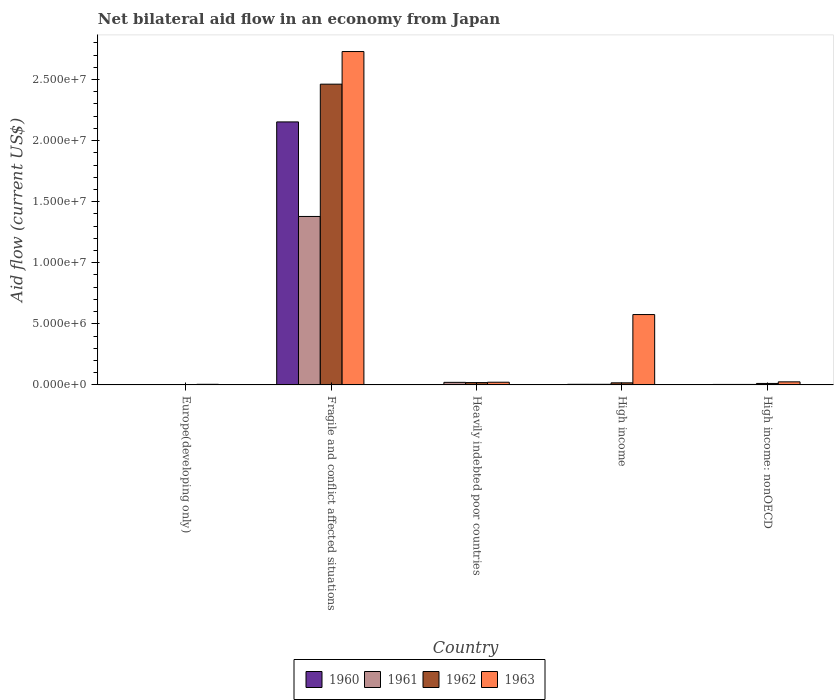How many groups of bars are there?
Your answer should be very brief. 5. Are the number of bars per tick equal to the number of legend labels?
Your answer should be compact. Yes. How many bars are there on the 1st tick from the left?
Ensure brevity in your answer.  4. What is the label of the 3rd group of bars from the left?
Ensure brevity in your answer.  Heavily indebted poor countries. In how many cases, is the number of bars for a given country not equal to the number of legend labels?
Offer a very short reply. 0. Across all countries, what is the maximum net bilateral aid flow in 1963?
Provide a short and direct response. 2.73e+07. Across all countries, what is the minimum net bilateral aid flow in 1960?
Provide a short and direct response. 10000. In which country was the net bilateral aid flow in 1960 maximum?
Offer a terse response. Fragile and conflict affected situations. In which country was the net bilateral aid flow in 1961 minimum?
Offer a very short reply. Europe(developing only). What is the total net bilateral aid flow in 1961 in the graph?
Make the answer very short. 1.41e+07. What is the difference between the net bilateral aid flow in 1962 in Fragile and conflict affected situations and the net bilateral aid flow in 1963 in High income?
Your answer should be compact. 1.89e+07. What is the average net bilateral aid flow in 1962 per country?
Make the answer very short. 5.03e+06. What is the difference between the net bilateral aid flow of/in 1961 and net bilateral aid flow of/in 1960 in Heavily indebted poor countries?
Your answer should be compact. 1.90e+05. In how many countries, is the net bilateral aid flow in 1963 greater than 19000000 US$?
Keep it short and to the point. 1. What is the ratio of the net bilateral aid flow in 1961 in Europe(developing only) to that in High income: nonOECD?
Offer a terse response. 0.75. Is the net bilateral aid flow in 1962 in Europe(developing only) less than that in High income: nonOECD?
Ensure brevity in your answer.  Yes. What is the difference between the highest and the second highest net bilateral aid flow in 1960?
Ensure brevity in your answer.  2.15e+07. What is the difference between the highest and the lowest net bilateral aid flow in 1962?
Provide a short and direct response. 2.46e+07. Is the sum of the net bilateral aid flow in 1961 in Europe(developing only) and High income: nonOECD greater than the maximum net bilateral aid flow in 1963 across all countries?
Provide a succinct answer. No. Is it the case that in every country, the sum of the net bilateral aid flow in 1961 and net bilateral aid flow in 1963 is greater than the sum of net bilateral aid flow in 1960 and net bilateral aid flow in 1962?
Make the answer very short. No. What does the 2nd bar from the left in High income: nonOECD represents?
Ensure brevity in your answer.  1961. What does the 2nd bar from the right in Heavily indebted poor countries represents?
Make the answer very short. 1962. What is the difference between two consecutive major ticks on the Y-axis?
Provide a succinct answer. 5.00e+06. How are the legend labels stacked?
Your answer should be very brief. Horizontal. What is the title of the graph?
Offer a very short reply. Net bilateral aid flow in an economy from Japan. Does "1968" appear as one of the legend labels in the graph?
Your answer should be very brief. No. What is the label or title of the Y-axis?
Give a very brief answer. Aid flow (current US$). What is the Aid flow (current US$) of 1961 in Europe(developing only)?
Offer a very short reply. 3.00e+04. What is the Aid flow (current US$) in 1963 in Europe(developing only)?
Give a very brief answer. 5.00e+04. What is the Aid flow (current US$) in 1960 in Fragile and conflict affected situations?
Provide a succinct answer. 2.15e+07. What is the Aid flow (current US$) of 1961 in Fragile and conflict affected situations?
Provide a succinct answer. 1.38e+07. What is the Aid flow (current US$) of 1962 in Fragile and conflict affected situations?
Offer a very short reply. 2.46e+07. What is the Aid flow (current US$) of 1963 in Fragile and conflict affected situations?
Ensure brevity in your answer.  2.73e+07. What is the Aid flow (current US$) of 1960 in Heavily indebted poor countries?
Your response must be concise. 2.00e+04. What is the Aid flow (current US$) of 1962 in Heavily indebted poor countries?
Your response must be concise. 1.90e+05. What is the Aid flow (current US$) of 1960 in High income?
Provide a succinct answer. 5.00e+04. What is the Aid flow (current US$) in 1961 in High income?
Provide a short and direct response. 5.00e+04. What is the Aid flow (current US$) of 1963 in High income?
Offer a very short reply. 5.76e+06. What is the Aid flow (current US$) in 1961 in High income: nonOECD?
Make the answer very short. 4.00e+04. What is the Aid flow (current US$) of 1962 in High income: nonOECD?
Give a very brief answer. 1.20e+05. What is the Aid flow (current US$) in 1963 in High income: nonOECD?
Your answer should be very brief. 2.50e+05. Across all countries, what is the maximum Aid flow (current US$) of 1960?
Provide a short and direct response. 2.15e+07. Across all countries, what is the maximum Aid flow (current US$) of 1961?
Your response must be concise. 1.38e+07. Across all countries, what is the maximum Aid flow (current US$) of 1962?
Your answer should be compact. 2.46e+07. Across all countries, what is the maximum Aid flow (current US$) in 1963?
Your response must be concise. 2.73e+07. Across all countries, what is the minimum Aid flow (current US$) of 1960?
Your answer should be compact. 10000. Across all countries, what is the minimum Aid flow (current US$) in 1961?
Ensure brevity in your answer.  3.00e+04. Across all countries, what is the minimum Aid flow (current US$) of 1962?
Offer a terse response. 3.00e+04. Across all countries, what is the minimum Aid flow (current US$) in 1963?
Keep it short and to the point. 5.00e+04. What is the total Aid flow (current US$) of 1960 in the graph?
Your answer should be compact. 2.16e+07. What is the total Aid flow (current US$) in 1961 in the graph?
Offer a terse response. 1.41e+07. What is the total Aid flow (current US$) of 1962 in the graph?
Keep it short and to the point. 2.51e+07. What is the total Aid flow (current US$) of 1963 in the graph?
Your answer should be very brief. 3.36e+07. What is the difference between the Aid flow (current US$) of 1960 in Europe(developing only) and that in Fragile and conflict affected situations?
Your answer should be compact. -2.15e+07. What is the difference between the Aid flow (current US$) in 1961 in Europe(developing only) and that in Fragile and conflict affected situations?
Your answer should be compact. -1.38e+07. What is the difference between the Aid flow (current US$) of 1962 in Europe(developing only) and that in Fragile and conflict affected situations?
Make the answer very short. -2.46e+07. What is the difference between the Aid flow (current US$) in 1963 in Europe(developing only) and that in Fragile and conflict affected situations?
Give a very brief answer. -2.72e+07. What is the difference between the Aid flow (current US$) in 1960 in Europe(developing only) and that in Heavily indebted poor countries?
Offer a very short reply. -10000. What is the difference between the Aid flow (current US$) of 1961 in Europe(developing only) and that in Heavily indebted poor countries?
Provide a succinct answer. -1.80e+05. What is the difference between the Aid flow (current US$) in 1960 in Europe(developing only) and that in High income?
Your answer should be compact. -4.00e+04. What is the difference between the Aid flow (current US$) of 1962 in Europe(developing only) and that in High income?
Ensure brevity in your answer.  -1.40e+05. What is the difference between the Aid flow (current US$) of 1963 in Europe(developing only) and that in High income?
Ensure brevity in your answer.  -5.71e+06. What is the difference between the Aid flow (current US$) in 1960 in Europe(developing only) and that in High income: nonOECD?
Make the answer very short. -3.00e+04. What is the difference between the Aid flow (current US$) in 1962 in Europe(developing only) and that in High income: nonOECD?
Give a very brief answer. -9.00e+04. What is the difference between the Aid flow (current US$) of 1963 in Europe(developing only) and that in High income: nonOECD?
Your response must be concise. -2.00e+05. What is the difference between the Aid flow (current US$) in 1960 in Fragile and conflict affected situations and that in Heavily indebted poor countries?
Give a very brief answer. 2.15e+07. What is the difference between the Aid flow (current US$) in 1961 in Fragile and conflict affected situations and that in Heavily indebted poor countries?
Make the answer very short. 1.36e+07. What is the difference between the Aid flow (current US$) of 1962 in Fragile and conflict affected situations and that in Heavily indebted poor countries?
Your answer should be very brief. 2.44e+07. What is the difference between the Aid flow (current US$) of 1963 in Fragile and conflict affected situations and that in Heavily indebted poor countries?
Your answer should be compact. 2.71e+07. What is the difference between the Aid flow (current US$) in 1960 in Fragile and conflict affected situations and that in High income?
Ensure brevity in your answer.  2.15e+07. What is the difference between the Aid flow (current US$) of 1961 in Fragile and conflict affected situations and that in High income?
Provide a short and direct response. 1.37e+07. What is the difference between the Aid flow (current US$) in 1962 in Fragile and conflict affected situations and that in High income?
Offer a very short reply. 2.44e+07. What is the difference between the Aid flow (current US$) in 1963 in Fragile and conflict affected situations and that in High income?
Offer a very short reply. 2.15e+07. What is the difference between the Aid flow (current US$) in 1960 in Fragile and conflict affected situations and that in High income: nonOECD?
Give a very brief answer. 2.15e+07. What is the difference between the Aid flow (current US$) in 1961 in Fragile and conflict affected situations and that in High income: nonOECD?
Ensure brevity in your answer.  1.38e+07. What is the difference between the Aid flow (current US$) of 1962 in Fragile and conflict affected situations and that in High income: nonOECD?
Offer a very short reply. 2.45e+07. What is the difference between the Aid flow (current US$) of 1963 in Fragile and conflict affected situations and that in High income: nonOECD?
Your answer should be compact. 2.70e+07. What is the difference between the Aid flow (current US$) in 1961 in Heavily indebted poor countries and that in High income?
Offer a very short reply. 1.60e+05. What is the difference between the Aid flow (current US$) in 1963 in Heavily indebted poor countries and that in High income?
Offer a terse response. -5.54e+06. What is the difference between the Aid flow (current US$) of 1960 in Heavily indebted poor countries and that in High income: nonOECD?
Ensure brevity in your answer.  -2.00e+04. What is the difference between the Aid flow (current US$) in 1961 in Heavily indebted poor countries and that in High income: nonOECD?
Your answer should be very brief. 1.70e+05. What is the difference between the Aid flow (current US$) of 1963 in Heavily indebted poor countries and that in High income: nonOECD?
Make the answer very short. -3.00e+04. What is the difference between the Aid flow (current US$) in 1962 in High income and that in High income: nonOECD?
Give a very brief answer. 5.00e+04. What is the difference between the Aid flow (current US$) in 1963 in High income and that in High income: nonOECD?
Keep it short and to the point. 5.51e+06. What is the difference between the Aid flow (current US$) of 1960 in Europe(developing only) and the Aid flow (current US$) of 1961 in Fragile and conflict affected situations?
Offer a very short reply. -1.38e+07. What is the difference between the Aid flow (current US$) in 1960 in Europe(developing only) and the Aid flow (current US$) in 1962 in Fragile and conflict affected situations?
Offer a terse response. -2.46e+07. What is the difference between the Aid flow (current US$) in 1960 in Europe(developing only) and the Aid flow (current US$) in 1963 in Fragile and conflict affected situations?
Your answer should be very brief. -2.73e+07. What is the difference between the Aid flow (current US$) of 1961 in Europe(developing only) and the Aid flow (current US$) of 1962 in Fragile and conflict affected situations?
Keep it short and to the point. -2.46e+07. What is the difference between the Aid flow (current US$) in 1961 in Europe(developing only) and the Aid flow (current US$) in 1963 in Fragile and conflict affected situations?
Provide a succinct answer. -2.73e+07. What is the difference between the Aid flow (current US$) in 1962 in Europe(developing only) and the Aid flow (current US$) in 1963 in Fragile and conflict affected situations?
Provide a succinct answer. -2.73e+07. What is the difference between the Aid flow (current US$) in 1960 in Europe(developing only) and the Aid flow (current US$) in 1961 in Heavily indebted poor countries?
Make the answer very short. -2.00e+05. What is the difference between the Aid flow (current US$) of 1960 in Europe(developing only) and the Aid flow (current US$) of 1963 in Heavily indebted poor countries?
Provide a short and direct response. -2.10e+05. What is the difference between the Aid flow (current US$) of 1961 in Europe(developing only) and the Aid flow (current US$) of 1962 in Heavily indebted poor countries?
Provide a short and direct response. -1.60e+05. What is the difference between the Aid flow (current US$) of 1962 in Europe(developing only) and the Aid flow (current US$) of 1963 in Heavily indebted poor countries?
Make the answer very short. -1.90e+05. What is the difference between the Aid flow (current US$) in 1960 in Europe(developing only) and the Aid flow (current US$) in 1963 in High income?
Offer a terse response. -5.75e+06. What is the difference between the Aid flow (current US$) in 1961 in Europe(developing only) and the Aid flow (current US$) in 1963 in High income?
Give a very brief answer. -5.73e+06. What is the difference between the Aid flow (current US$) of 1962 in Europe(developing only) and the Aid flow (current US$) of 1963 in High income?
Make the answer very short. -5.73e+06. What is the difference between the Aid flow (current US$) of 1960 in Europe(developing only) and the Aid flow (current US$) of 1961 in High income: nonOECD?
Your response must be concise. -3.00e+04. What is the difference between the Aid flow (current US$) in 1960 in Europe(developing only) and the Aid flow (current US$) in 1963 in High income: nonOECD?
Your answer should be compact. -2.40e+05. What is the difference between the Aid flow (current US$) of 1961 in Europe(developing only) and the Aid flow (current US$) of 1962 in High income: nonOECD?
Ensure brevity in your answer.  -9.00e+04. What is the difference between the Aid flow (current US$) in 1960 in Fragile and conflict affected situations and the Aid flow (current US$) in 1961 in Heavily indebted poor countries?
Ensure brevity in your answer.  2.13e+07. What is the difference between the Aid flow (current US$) of 1960 in Fragile and conflict affected situations and the Aid flow (current US$) of 1962 in Heavily indebted poor countries?
Offer a terse response. 2.13e+07. What is the difference between the Aid flow (current US$) in 1960 in Fragile and conflict affected situations and the Aid flow (current US$) in 1963 in Heavily indebted poor countries?
Offer a terse response. 2.13e+07. What is the difference between the Aid flow (current US$) in 1961 in Fragile and conflict affected situations and the Aid flow (current US$) in 1962 in Heavily indebted poor countries?
Give a very brief answer. 1.36e+07. What is the difference between the Aid flow (current US$) in 1961 in Fragile and conflict affected situations and the Aid flow (current US$) in 1963 in Heavily indebted poor countries?
Ensure brevity in your answer.  1.36e+07. What is the difference between the Aid flow (current US$) of 1962 in Fragile and conflict affected situations and the Aid flow (current US$) of 1963 in Heavily indebted poor countries?
Ensure brevity in your answer.  2.44e+07. What is the difference between the Aid flow (current US$) of 1960 in Fragile and conflict affected situations and the Aid flow (current US$) of 1961 in High income?
Offer a terse response. 2.15e+07. What is the difference between the Aid flow (current US$) in 1960 in Fragile and conflict affected situations and the Aid flow (current US$) in 1962 in High income?
Provide a short and direct response. 2.14e+07. What is the difference between the Aid flow (current US$) of 1960 in Fragile and conflict affected situations and the Aid flow (current US$) of 1963 in High income?
Make the answer very short. 1.58e+07. What is the difference between the Aid flow (current US$) in 1961 in Fragile and conflict affected situations and the Aid flow (current US$) in 1962 in High income?
Provide a succinct answer. 1.36e+07. What is the difference between the Aid flow (current US$) in 1961 in Fragile and conflict affected situations and the Aid flow (current US$) in 1963 in High income?
Make the answer very short. 8.03e+06. What is the difference between the Aid flow (current US$) of 1962 in Fragile and conflict affected situations and the Aid flow (current US$) of 1963 in High income?
Make the answer very short. 1.89e+07. What is the difference between the Aid flow (current US$) of 1960 in Fragile and conflict affected situations and the Aid flow (current US$) of 1961 in High income: nonOECD?
Ensure brevity in your answer.  2.15e+07. What is the difference between the Aid flow (current US$) of 1960 in Fragile and conflict affected situations and the Aid flow (current US$) of 1962 in High income: nonOECD?
Offer a terse response. 2.14e+07. What is the difference between the Aid flow (current US$) in 1960 in Fragile and conflict affected situations and the Aid flow (current US$) in 1963 in High income: nonOECD?
Keep it short and to the point. 2.13e+07. What is the difference between the Aid flow (current US$) in 1961 in Fragile and conflict affected situations and the Aid flow (current US$) in 1962 in High income: nonOECD?
Keep it short and to the point. 1.37e+07. What is the difference between the Aid flow (current US$) of 1961 in Fragile and conflict affected situations and the Aid flow (current US$) of 1963 in High income: nonOECD?
Offer a terse response. 1.35e+07. What is the difference between the Aid flow (current US$) of 1962 in Fragile and conflict affected situations and the Aid flow (current US$) of 1963 in High income: nonOECD?
Give a very brief answer. 2.44e+07. What is the difference between the Aid flow (current US$) of 1960 in Heavily indebted poor countries and the Aid flow (current US$) of 1961 in High income?
Offer a very short reply. -3.00e+04. What is the difference between the Aid flow (current US$) of 1960 in Heavily indebted poor countries and the Aid flow (current US$) of 1963 in High income?
Give a very brief answer. -5.74e+06. What is the difference between the Aid flow (current US$) in 1961 in Heavily indebted poor countries and the Aid flow (current US$) in 1962 in High income?
Offer a very short reply. 4.00e+04. What is the difference between the Aid flow (current US$) of 1961 in Heavily indebted poor countries and the Aid flow (current US$) of 1963 in High income?
Offer a terse response. -5.55e+06. What is the difference between the Aid flow (current US$) in 1962 in Heavily indebted poor countries and the Aid flow (current US$) in 1963 in High income?
Your response must be concise. -5.57e+06. What is the difference between the Aid flow (current US$) in 1960 in Heavily indebted poor countries and the Aid flow (current US$) in 1961 in High income: nonOECD?
Provide a succinct answer. -2.00e+04. What is the difference between the Aid flow (current US$) in 1960 in Heavily indebted poor countries and the Aid flow (current US$) in 1963 in High income: nonOECD?
Your answer should be very brief. -2.30e+05. What is the difference between the Aid flow (current US$) in 1961 in Heavily indebted poor countries and the Aid flow (current US$) in 1963 in High income: nonOECD?
Make the answer very short. -4.00e+04. What is the difference between the Aid flow (current US$) in 1962 in Heavily indebted poor countries and the Aid flow (current US$) in 1963 in High income: nonOECD?
Give a very brief answer. -6.00e+04. What is the difference between the Aid flow (current US$) in 1960 in High income and the Aid flow (current US$) in 1961 in High income: nonOECD?
Your response must be concise. 10000. What is the difference between the Aid flow (current US$) in 1961 in High income and the Aid flow (current US$) in 1962 in High income: nonOECD?
Provide a succinct answer. -7.00e+04. What is the difference between the Aid flow (current US$) of 1961 in High income and the Aid flow (current US$) of 1963 in High income: nonOECD?
Keep it short and to the point. -2.00e+05. What is the difference between the Aid flow (current US$) of 1962 in High income and the Aid flow (current US$) of 1963 in High income: nonOECD?
Ensure brevity in your answer.  -8.00e+04. What is the average Aid flow (current US$) of 1960 per country?
Your response must be concise. 4.33e+06. What is the average Aid flow (current US$) in 1961 per country?
Make the answer very short. 2.82e+06. What is the average Aid flow (current US$) in 1962 per country?
Keep it short and to the point. 5.03e+06. What is the average Aid flow (current US$) in 1963 per country?
Your answer should be very brief. 6.71e+06. What is the difference between the Aid flow (current US$) of 1960 and Aid flow (current US$) of 1962 in Europe(developing only)?
Make the answer very short. -2.00e+04. What is the difference between the Aid flow (current US$) of 1961 and Aid flow (current US$) of 1962 in Europe(developing only)?
Your response must be concise. 0. What is the difference between the Aid flow (current US$) in 1961 and Aid flow (current US$) in 1963 in Europe(developing only)?
Give a very brief answer. -2.00e+04. What is the difference between the Aid flow (current US$) in 1962 and Aid flow (current US$) in 1963 in Europe(developing only)?
Your answer should be very brief. -2.00e+04. What is the difference between the Aid flow (current US$) of 1960 and Aid flow (current US$) of 1961 in Fragile and conflict affected situations?
Ensure brevity in your answer.  7.74e+06. What is the difference between the Aid flow (current US$) of 1960 and Aid flow (current US$) of 1962 in Fragile and conflict affected situations?
Provide a succinct answer. -3.09e+06. What is the difference between the Aid flow (current US$) in 1960 and Aid flow (current US$) in 1963 in Fragile and conflict affected situations?
Your response must be concise. -5.76e+06. What is the difference between the Aid flow (current US$) of 1961 and Aid flow (current US$) of 1962 in Fragile and conflict affected situations?
Provide a short and direct response. -1.08e+07. What is the difference between the Aid flow (current US$) in 1961 and Aid flow (current US$) in 1963 in Fragile and conflict affected situations?
Provide a short and direct response. -1.35e+07. What is the difference between the Aid flow (current US$) in 1962 and Aid flow (current US$) in 1963 in Fragile and conflict affected situations?
Ensure brevity in your answer.  -2.67e+06. What is the difference between the Aid flow (current US$) in 1960 and Aid flow (current US$) in 1961 in Heavily indebted poor countries?
Offer a very short reply. -1.90e+05. What is the difference between the Aid flow (current US$) of 1960 and Aid flow (current US$) of 1962 in Heavily indebted poor countries?
Provide a short and direct response. -1.70e+05. What is the difference between the Aid flow (current US$) of 1960 and Aid flow (current US$) of 1963 in Heavily indebted poor countries?
Keep it short and to the point. -2.00e+05. What is the difference between the Aid flow (current US$) in 1961 and Aid flow (current US$) in 1962 in Heavily indebted poor countries?
Offer a terse response. 2.00e+04. What is the difference between the Aid flow (current US$) of 1962 and Aid flow (current US$) of 1963 in Heavily indebted poor countries?
Your response must be concise. -3.00e+04. What is the difference between the Aid flow (current US$) in 1960 and Aid flow (current US$) in 1961 in High income?
Provide a succinct answer. 0. What is the difference between the Aid flow (current US$) in 1960 and Aid flow (current US$) in 1962 in High income?
Keep it short and to the point. -1.20e+05. What is the difference between the Aid flow (current US$) of 1960 and Aid flow (current US$) of 1963 in High income?
Provide a succinct answer. -5.71e+06. What is the difference between the Aid flow (current US$) of 1961 and Aid flow (current US$) of 1962 in High income?
Your answer should be very brief. -1.20e+05. What is the difference between the Aid flow (current US$) in 1961 and Aid flow (current US$) in 1963 in High income?
Offer a terse response. -5.71e+06. What is the difference between the Aid flow (current US$) of 1962 and Aid flow (current US$) of 1963 in High income?
Keep it short and to the point. -5.59e+06. What is the difference between the Aid flow (current US$) in 1960 and Aid flow (current US$) in 1961 in High income: nonOECD?
Give a very brief answer. 0. What is the difference between the Aid flow (current US$) in 1960 and Aid flow (current US$) in 1962 in High income: nonOECD?
Offer a very short reply. -8.00e+04. What is the difference between the Aid flow (current US$) of 1960 and Aid flow (current US$) of 1963 in High income: nonOECD?
Your response must be concise. -2.10e+05. What is the difference between the Aid flow (current US$) of 1961 and Aid flow (current US$) of 1963 in High income: nonOECD?
Your response must be concise. -2.10e+05. What is the ratio of the Aid flow (current US$) of 1960 in Europe(developing only) to that in Fragile and conflict affected situations?
Offer a terse response. 0. What is the ratio of the Aid flow (current US$) in 1961 in Europe(developing only) to that in Fragile and conflict affected situations?
Give a very brief answer. 0. What is the ratio of the Aid flow (current US$) of 1962 in Europe(developing only) to that in Fragile and conflict affected situations?
Offer a terse response. 0. What is the ratio of the Aid flow (current US$) in 1963 in Europe(developing only) to that in Fragile and conflict affected situations?
Offer a terse response. 0. What is the ratio of the Aid flow (current US$) in 1960 in Europe(developing only) to that in Heavily indebted poor countries?
Offer a very short reply. 0.5. What is the ratio of the Aid flow (current US$) in 1961 in Europe(developing only) to that in Heavily indebted poor countries?
Your answer should be compact. 0.14. What is the ratio of the Aid flow (current US$) in 1962 in Europe(developing only) to that in Heavily indebted poor countries?
Offer a terse response. 0.16. What is the ratio of the Aid flow (current US$) in 1963 in Europe(developing only) to that in Heavily indebted poor countries?
Give a very brief answer. 0.23. What is the ratio of the Aid flow (current US$) in 1961 in Europe(developing only) to that in High income?
Make the answer very short. 0.6. What is the ratio of the Aid flow (current US$) of 1962 in Europe(developing only) to that in High income?
Offer a terse response. 0.18. What is the ratio of the Aid flow (current US$) of 1963 in Europe(developing only) to that in High income?
Offer a very short reply. 0.01. What is the ratio of the Aid flow (current US$) of 1960 in Europe(developing only) to that in High income: nonOECD?
Give a very brief answer. 0.25. What is the ratio of the Aid flow (current US$) of 1961 in Europe(developing only) to that in High income: nonOECD?
Offer a very short reply. 0.75. What is the ratio of the Aid flow (current US$) of 1960 in Fragile and conflict affected situations to that in Heavily indebted poor countries?
Ensure brevity in your answer.  1076.5. What is the ratio of the Aid flow (current US$) of 1961 in Fragile and conflict affected situations to that in Heavily indebted poor countries?
Provide a short and direct response. 65.67. What is the ratio of the Aid flow (current US$) in 1962 in Fragile and conflict affected situations to that in Heavily indebted poor countries?
Offer a terse response. 129.58. What is the ratio of the Aid flow (current US$) in 1963 in Fragile and conflict affected situations to that in Heavily indebted poor countries?
Provide a short and direct response. 124.05. What is the ratio of the Aid flow (current US$) in 1960 in Fragile and conflict affected situations to that in High income?
Offer a very short reply. 430.6. What is the ratio of the Aid flow (current US$) in 1961 in Fragile and conflict affected situations to that in High income?
Provide a succinct answer. 275.8. What is the ratio of the Aid flow (current US$) in 1962 in Fragile and conflict affected situations to that in High income?
Ensure brevity in your answer.  144.82. What is the ratio of the Aid flow (current US$) of 1963 in Fragile and conflict affected situations to that in High income?
Provide a short and direct response. 4.74. What is the ratio of the Aid flow (current US$) in 1960 in Fragile and conflict affected situations to that in High income: nonOECD?
Ensure brevity in your answer.  538.25. What is the ratio of the Aid flow (current US$) in 1961 in Fragile and conflict affected situations to that in High income: nonOECD?
Give a very brief answer. 344.75. What is the ratio of the Aid flow (current US$) of 1962 in Fragile and conflict affected situations to that in High income: nonOECD?
Your answer should be very brief. 205.17. What is the ratio of the Aid flow (current US$) of 1963 in Fragile and conflict affected situations to that in High income: nonOECD?
Provide a succinct answer. 109.16. What is the ratio of the Aid flow (current US$) in 1961 in Heavily indebted poor countries to that in High income?
Your answer should be compact. 4.2. What is the ratio of the Aid flow (current US$) of 1962 in Heavily indebted poor countries to that in High income?
Offer a terse response. 1.12. What is the ratio of the Aid flow (current US$) in 1963 in Heavily indebted poor countries to that in High income?
Ensure brevity in your answer.  0.04. What is the ratio of the Aid flow (current US$) in 1960 in Heavily indebted poor countries to that in High income: nonOECD?
Keep it short and to the point. 0.5. What is the ratio of the Aid flow (current US$) of 1961 in Heavily indebted poor countries to that in High income: nonOECD?
Provide a succinct answer. 5.25. What is the ratio of the Aid flow (current US$) of 1962 in Heavily indebted poor countries to that in High income: nonOECD?
Provide a succinct answer. 1.58. What is the ratio of the Aid flow (current US$) of 1962 in High income to that in High income: nonOECD?
Offer a terse response. 1.42. What is the ratio of the Aid flow (current US$) of 1963 in High income to that in High income: nonOECD?
Your response must be concise. 23.04. What is the difference between the highest and the second highest Aid flow (current US$) in 1960?
Your answer should be compact. 2.15e+07. What is the difference between the highest and the second highest Aid flow (current US$) in 1961?
Give a very brief answer. 1.36e+07. What is the difference between the highest and the second highest Aid flow (current US$) of 1962?
Your answer should be very brief. 2.44e+07. What is the difference between the highest and the second highest Aid flow (current US$) of 1963?
Provide a short and direct response. 2.15e+07. What is the difference between the highest and the lowest Aid flow (current US$) of 1960?
Keep it short and to the point. 2.15e+07. What is the difference between the highest and the lowest Aid flow (current US$) in 1961?
Offer a terse response. 1.38e+07. What is the difference between the highest and the lowest Aid flow (current US$) of 1962?
Your answer should be very brief. 2.46e+07. What is the difference between the highest and the lowest Aid flow (current US$) in 1963?
Offer a very short reply. 2.72e+07. 